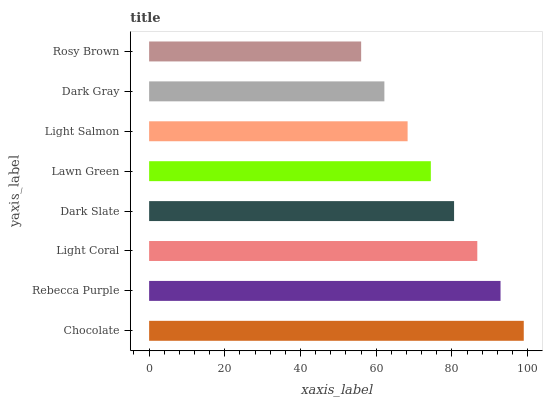Is Rosy Brown the minimum?
Answer yes or no. Yes. Is Chocolate the maximum?
Answer yes or no. Yes. Is Rebecca Purple the minimum?
Answer yes or no. No. Is Rebecca Purple the maximum?
Answer yes or no. No. Is Chocolate greater than Rebecca Purple?
Answer yes or no. Yes. Is Rebecca Purple less than Chocolate?
Answer yes or no. Yes. Is Rebecca Purple greater than Chocolate?
Answer yes or no. No. Is Chocolate less than Rebecca Purple?
Answer yes or no. No. Is Dark Slate the high median?
Answer yes or no. Yes. Is Lawn Green the low median?
Answer yes or no. Yes. Is Light Salmon the high median?
Answer yes or no. No. Is Light Salmon the low median?
Answer yes or no. No. 